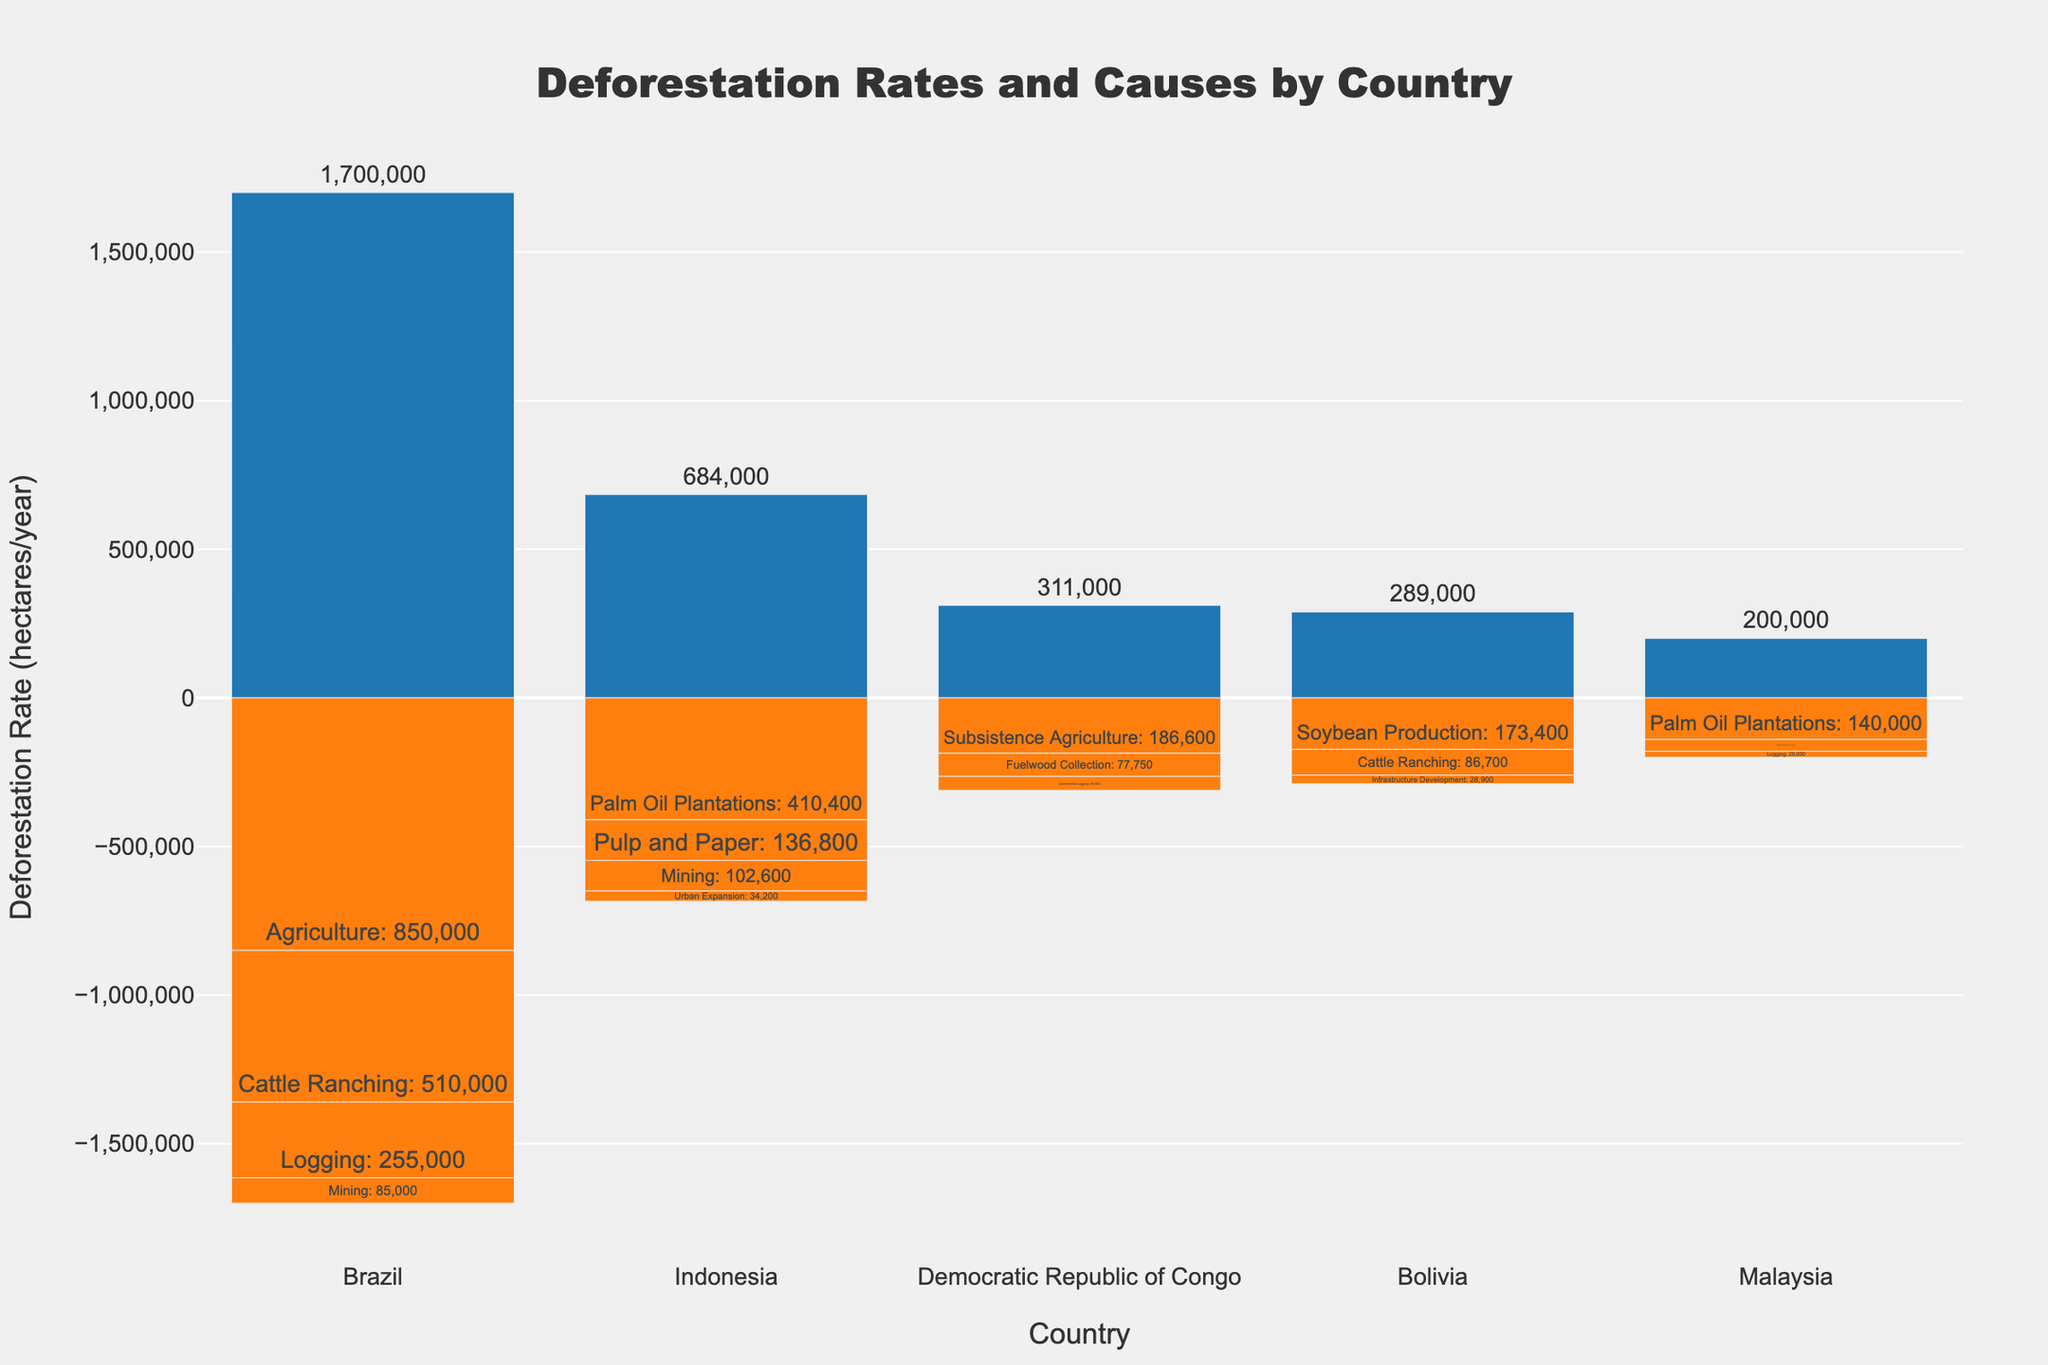What is the title of the chart? The title is usually placed at the top center of the chart and is designed to provide a concise description of what the chart represents. In this case, it would be "Deforestation Rates and Causes by Country" based on the data provided and the typical format of titled plots.
Answer: Deforestation Rates and Causes by Country What are the countries included in the chart? By looking at the x-axis, we can see the distinct categories for each country. From the provided data, the countries are Brazil, Indonesia, Democratic Republic of Congo, Bolivia, and Malaysia.
Answer: Brazil, Indonesia, Democratic Republic of Congo, Bolivia, Malaysia Which country has the highest total deforestation rate? Look at the total height of the bars for each country. The tallest bar indicates the highest total deforestation rate. Based on the data, Brazil has the highest total at 1,700,000 hectares/year.
Answer: Brazil How many distinct causes of deforestation are depicted for Bolivia? Inspect the different smaller bars stacked beneath the main total bar for Bolivia. There are three causes indicated: Soybean Production, Cattle Ranching, and Infrastructure Development.
Answer: 3 What is the combined deforestation rate from Palm Oil Plantations in Indonesia and Malaysia? Analyze the bars labeled 'Palm Oil Plantations' for Indonesia and Malaysia, then sum their values: 410,400 (Indonesia) + 140,000 (Malaysia).
Answer: 550,400 Which cause contributes the least to deforestation in Brazil? For Brazil, identify the smallest bar among the causes listed: Agriculture, Cattle Ranching, Logging, and Mining. The smallest value is for Mining, at 85,000 hectares/year.
Answer: Mining Between the Democratic Republic of Congo and Bolivia, which country's soybean production causes more deforestation? Compare the heights of the 'Soybean Production' bars for both countries. Since only Bolivia has an entry for Soybean Production with 173,400 hectares/year, Bolivia has more deforestation due to soybean production.
Answer: Bolivia What is the deforestation rate caused by Logging in Brazil, and how does it compare to Bolivia? Identify the bars for Logging in both countries. For Brazil, the rate is 255,000 hectares/year, and for Bolivia, there is no data for Logging. Therefore, Brazil has a higher rate.
Answer: 255,000; Brazil has higher How does the total deforestation rate in Indonesia compare to Malaysia? Compare the entire height of the bars for Indonesia and Malaysia. Indonesia's total is 684,000 hectares/year, while Malaysia's total is 200,000 hectares/year. Indonesia has a higher total deforestation rate.
Answer: Indonesia has a higher rate What is the total deforestation rate attributed to Urban Expansion in Indonesia? Refer to the bar labeled 'Urban Expansion' for Indonesia and note its height. According to the provided data, this is 34,200 hectares/year.
Answer: 34,200 